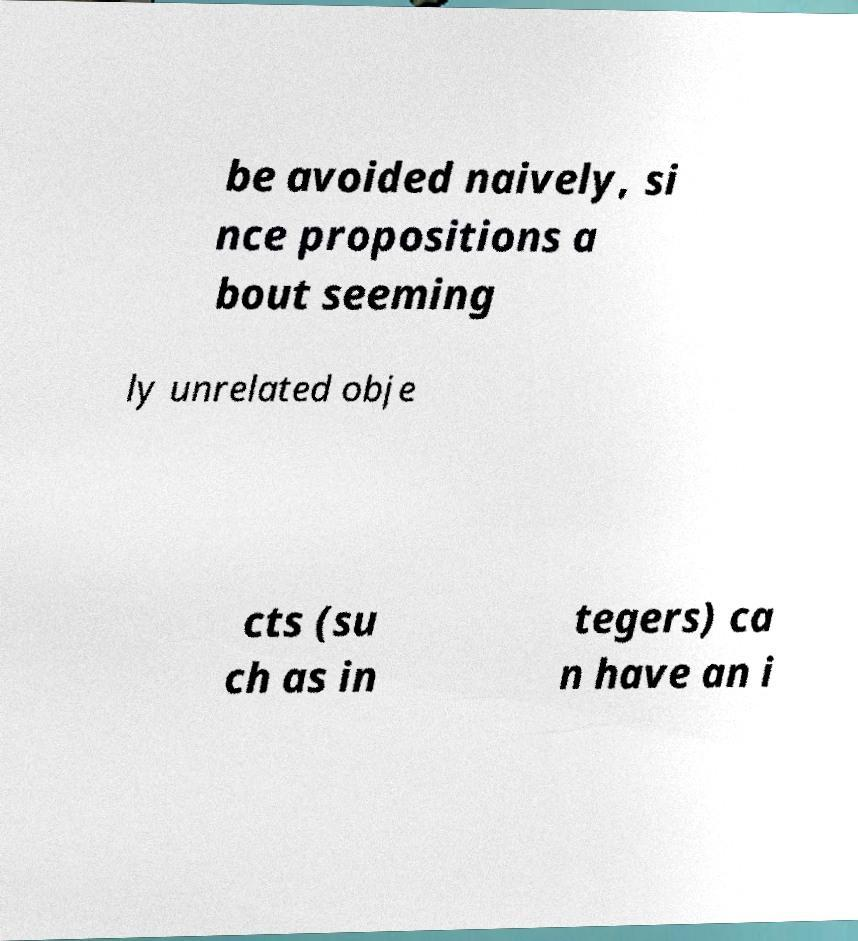I need the written content from this picture converted into text. Can you do that? be avoided naively, si nce propositions a bout seeming ly unrelated obje cts (su ch as in tegers) ca n have an i 